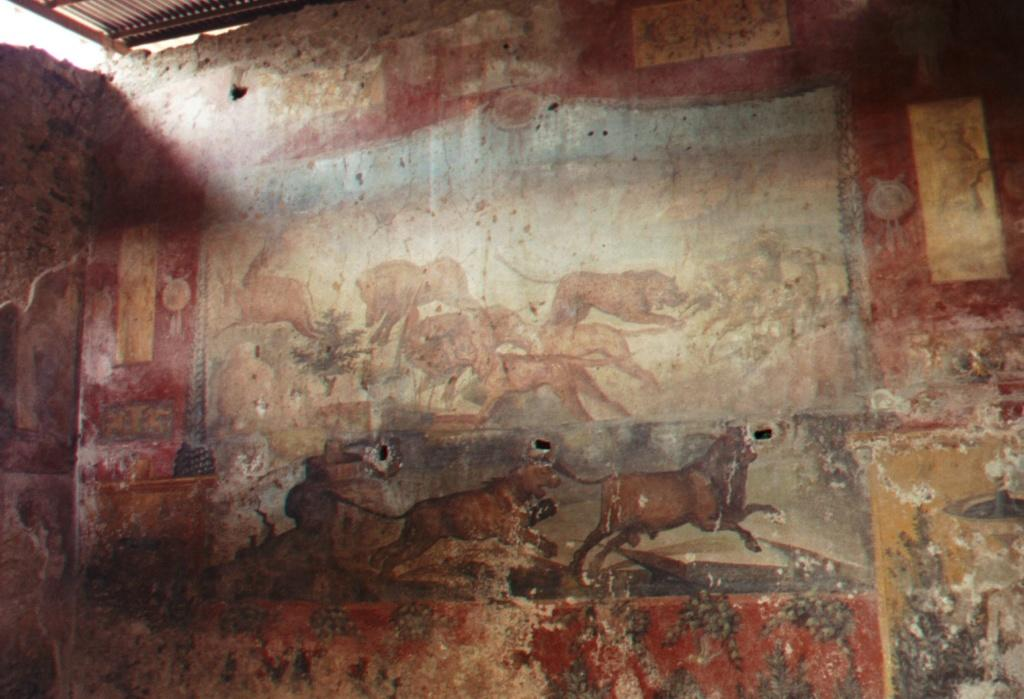What is present on the wall in the image? There are paintings of animals on the wall. Can you describe the paintings in more detail? Unfortunately, the provided facts do not give any additional information about the paintings. What type of wall is visible in the image? The facts only mention that there is a wall in the image, without providing any details about its material or appearance. How many babies are crawling on the wall in the image? There are no babies present in the image; it only features a wall with paintings of animals. 